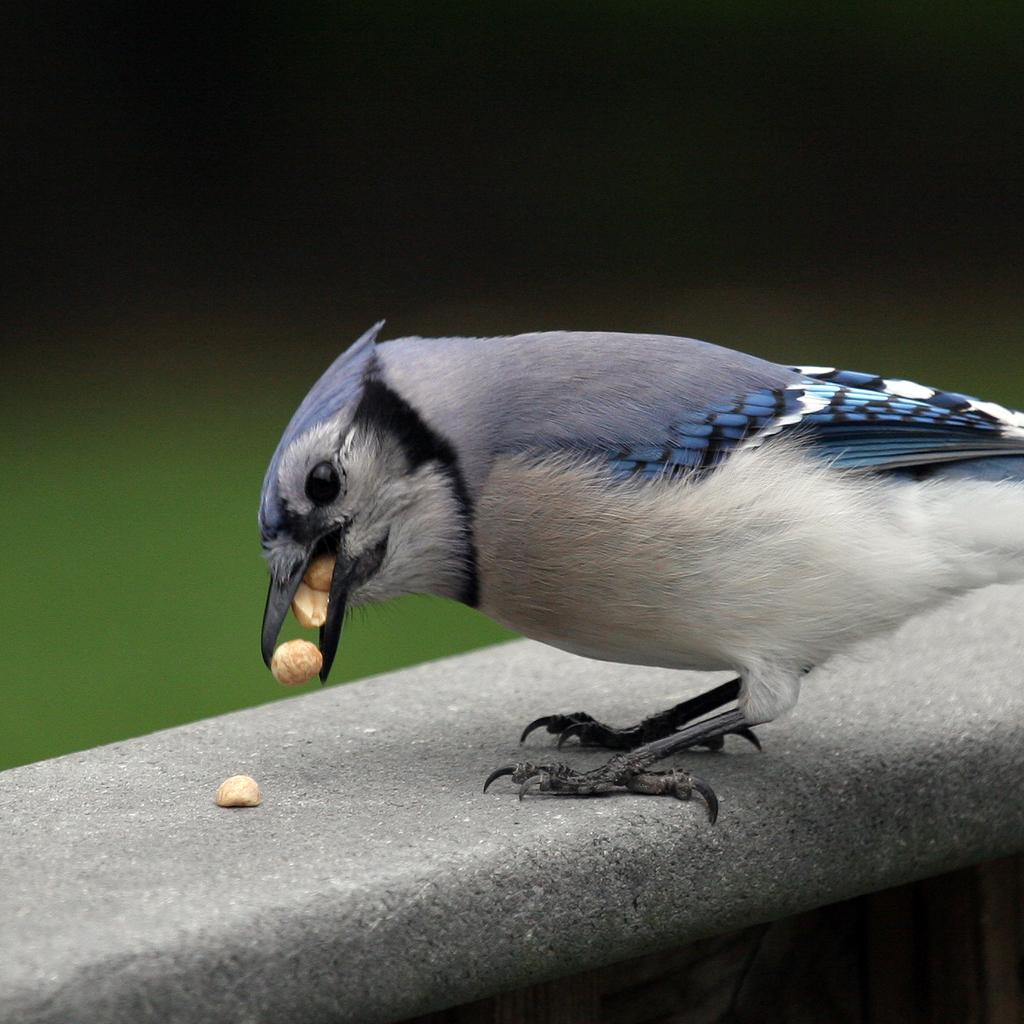What is the main subject in the center of the image? There is a bird in the center of the image. What is the bird doing in the image? The bird is standing on a wall and eating seeds. Can you describe the background of the image? The background of the image is blurry. What type of metal is the bird using to laugh in the image? There is no metal or laughter present in the image; it features a bird standing on a wall and eating seeds. 